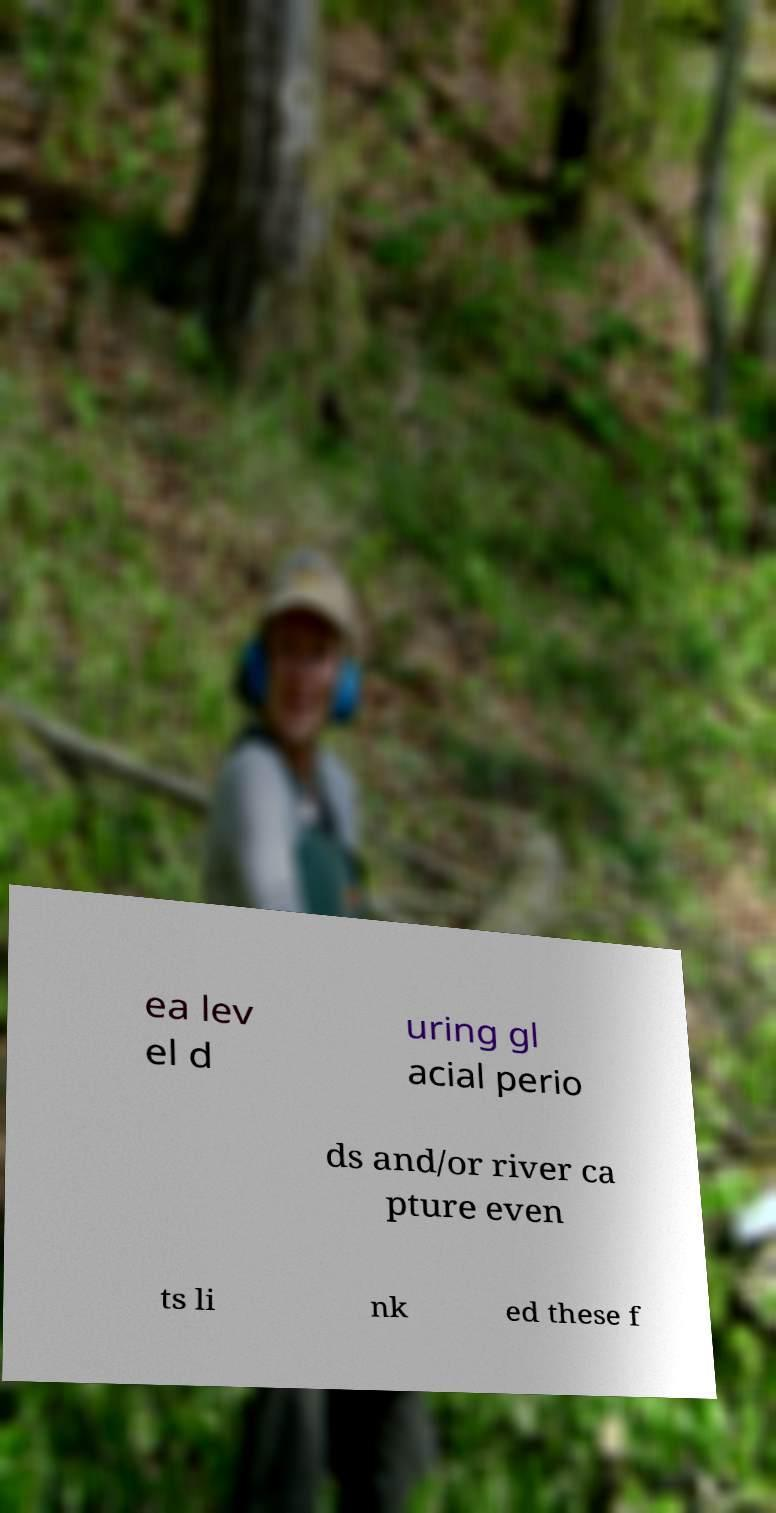Please identify and transcribe the text found in this image. ea lev el d uring gl acial perio ds and/or river ca pture even ts li nk ed these f 